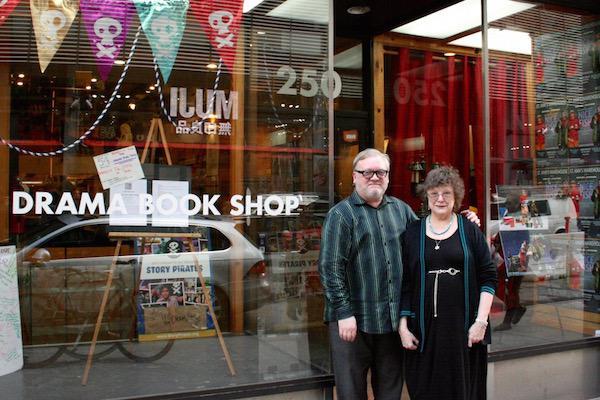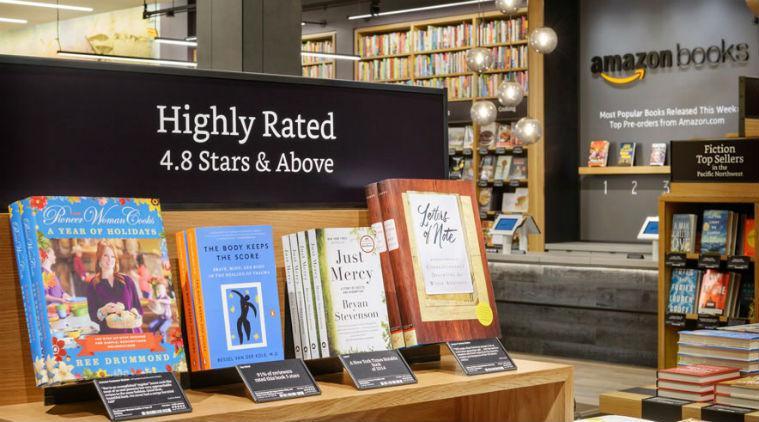The first image is the image on the left, the second image is the image on the right. For the images shown, is this caption "there are two people in the image on the left." true? Answer yes or no. Yes. The first image is the image on the left, the second image is the image on the right. Considering the images on both sides, is "One image is inside a bookshop and one image is outside a bookshop." valid? Answer yes or no. Yes. 